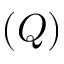<formula> <loc_0><loc_0><loc_500><loc_500>( Q )</formula> 